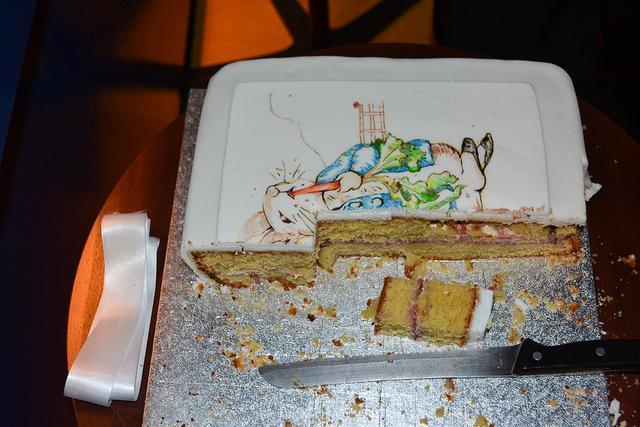Which age range may this cake have been for?
Choose the right answer and clarify with the format: 'Answer: answer
Rationale: rationale.'
Options: Child, grandparent, teenager, young adult. Answer: child.
Rationale: It had the picture of a cartoon character on it. 